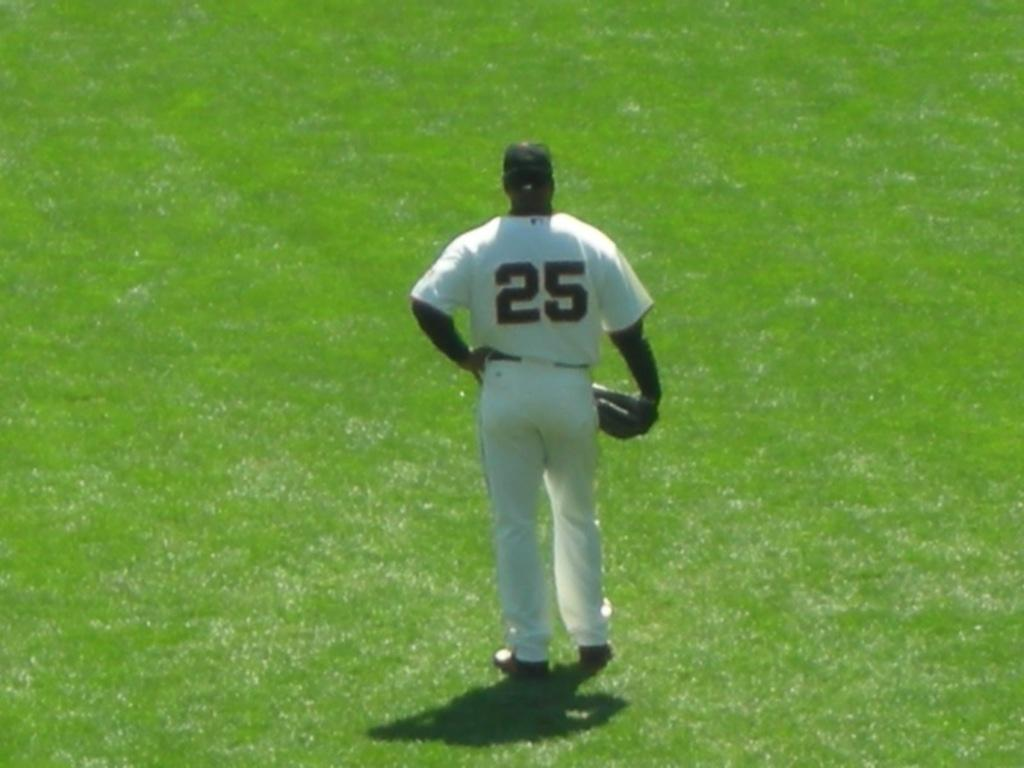<image>
Describe the image concisely. A baseball player wears the number 25 on his jersey. 